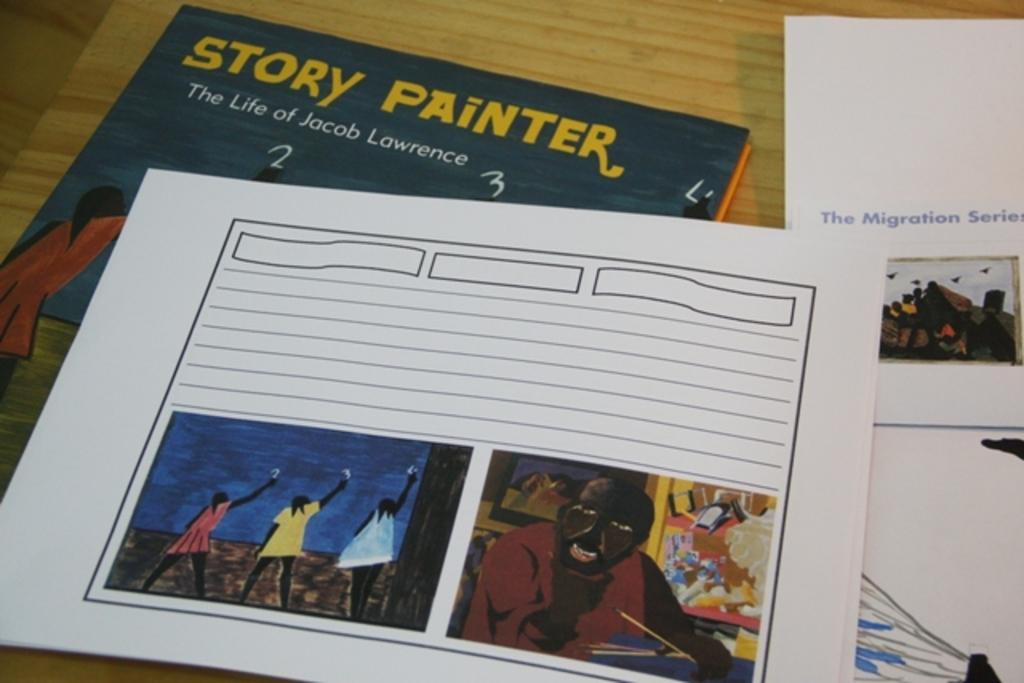<image>
Share a concise interpretation of the image provided. Pictures of paintings on top of the book Story Painter The Life of Jacob Lawrence. 